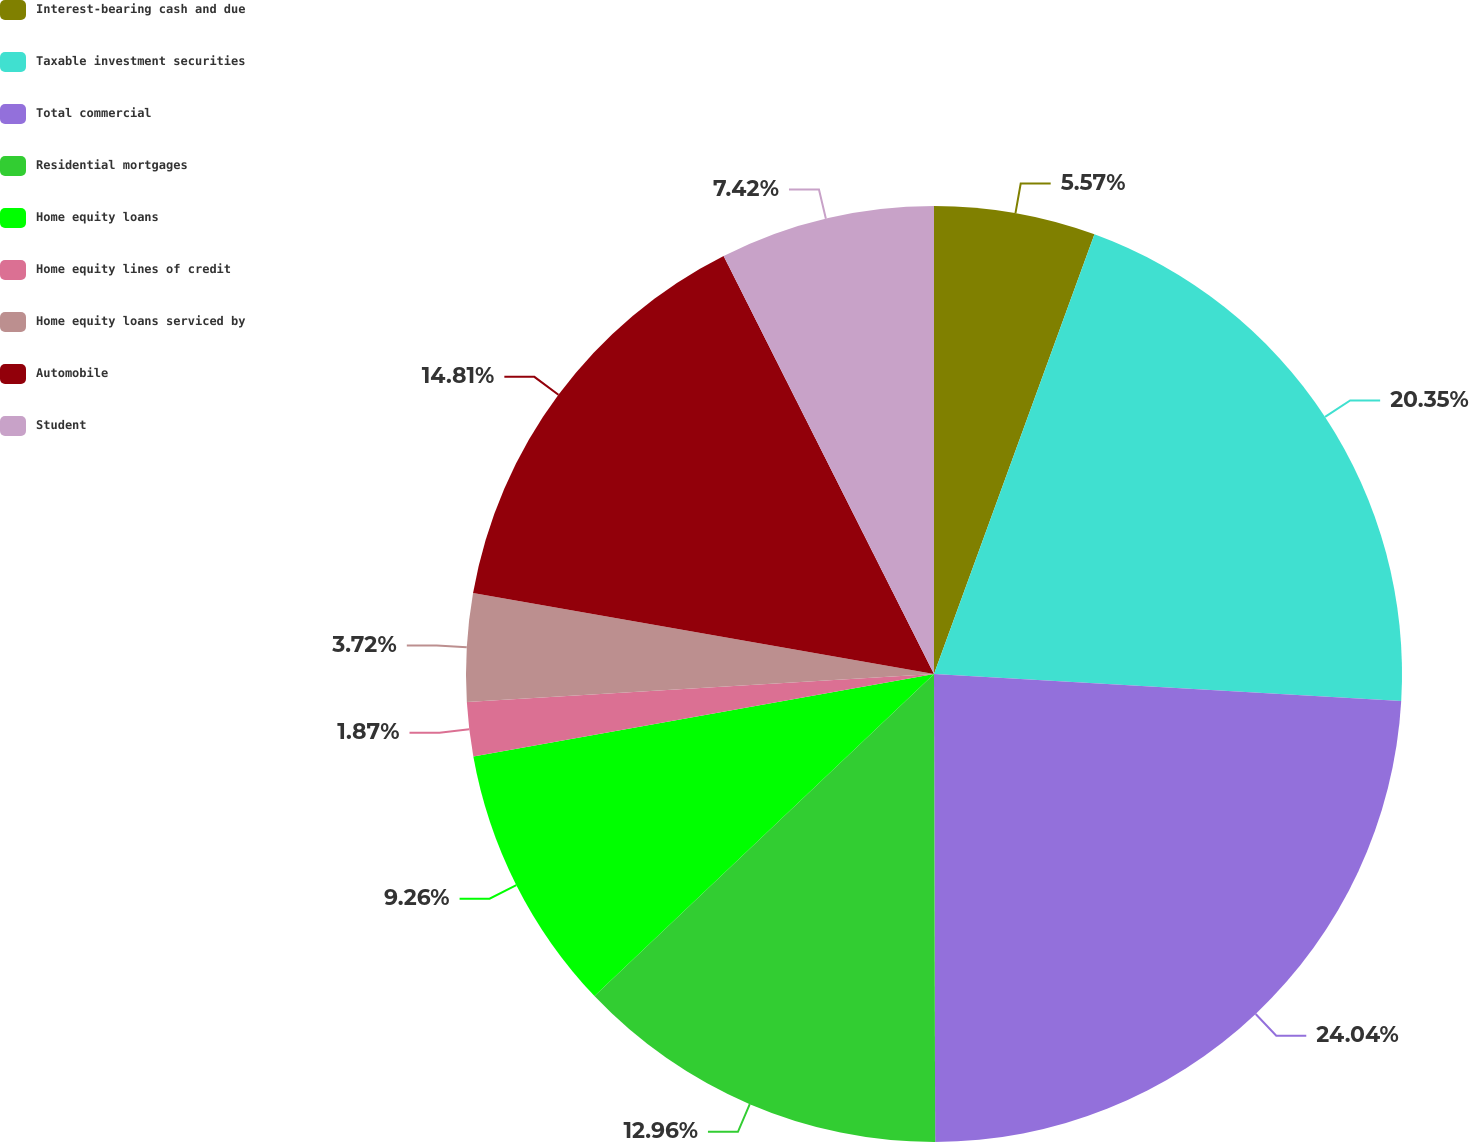Convert chart. <chart><loc_0><loc_0><loc_500><loc_500><pie_chart><fcel>Interest-bearing cash and due<fcel>Taxable investment securities<fcel>Total commercial<fcel>Residential mortgages<fcel>Home equity loans<fcel>Home equity lines of credit<fcel>Home equity loans serviced by<fcel>Automobile<fcel>Student<nl><fcel>5.57%<fcel>20.35%<fcel>24.04%<fcel>12.96%<fcel>9.26%<fcel>1.87%<fcel>3.72%<fcel>14.81%<fcel>7.42%<nl></chart> 